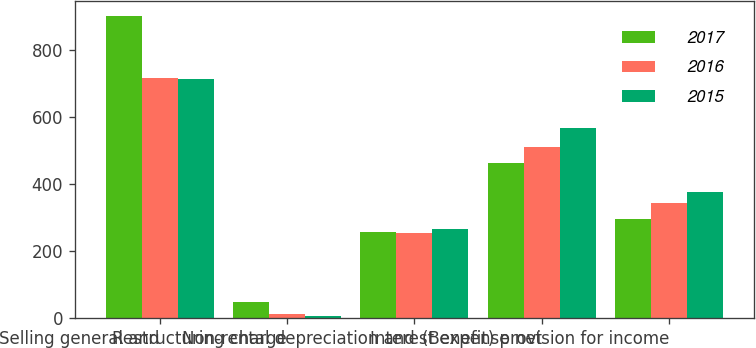Convert chart to OTSL. <chart><loc_0><loc_0><loc_500><loc_500><stacked_bar_chart><ecel><fcel>Selling general and<fcel>Restructuring charge<fcel>Non-rental depreciation and<fcel>Interest expense net<fcel>(Benefit) provision for income<nl><fcel>2017<fcel>903<fcel>50<fcel>259<fcel>464<fcel>298<nl><fcel>2016<fcel>719<fcel>14<fcel>255<fcel>511<fcel>343<nl><fcel>2015<fcel>714<fcel>6<fcel>268<fcel>567<fcel>378<nl></chart> 